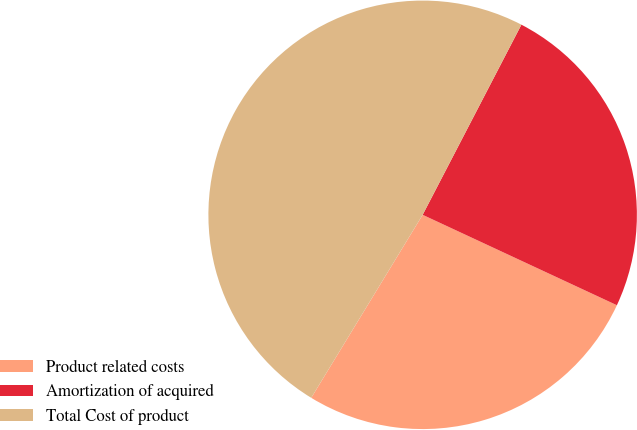Convert chart. <chart><loc_0><loc_0><loc_500><loc_500><pie_chart><fcel>Product related costs<fcel>Amortization of acquired<fcel>Total Cost of product<nl><fcel>26.77%<fcel>24.31%<fcel>48.92%<nl></chart> 